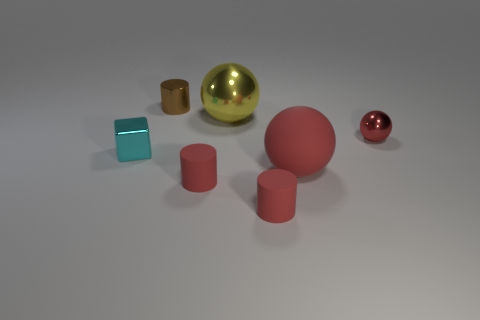Which of these objects appears to have the most reflective surface? The gold sphere in the front appears to have the most reflective surface. It stands out with its shiny texture that reflects the light and the environment, creating a sense of depth and realism within the image.  How does the lighting affect the mood of this image? The lighting in the image is soft and diffuse, casting gentle shadows and enhancing the objects' three-dimensionality. This subdued lighting gives the scene a calm and serene atmosphere, which is emphasized by the smooth surfaces and rounded edges of the shapes. 